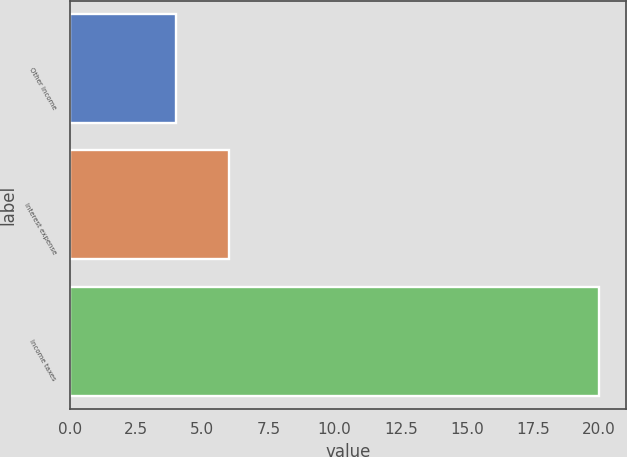Convert chart to OTSL. <chart><loc_0><loc_0><loc_500><loc_500><bar_chart><fcel>Other income<fcel>Interest expense<fcel>Income taxes<nl><fcel>4<fcel>6<fcel>20<nl></chart> 